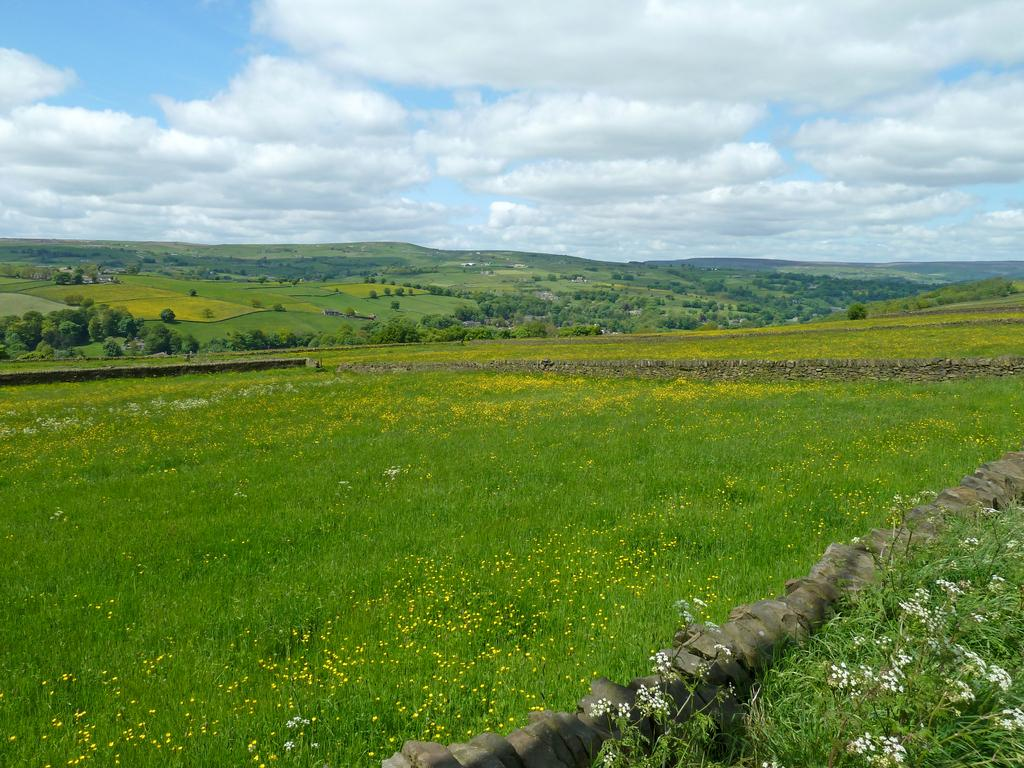What type of vegetation can be seen in the image? There is grass in the image, as well as plants and flowers at the bottom. What is visible in the background of the image? There are trees in the background of the image. What can be seen in the sky in the image? The sky is visible in the image, and clouds are present. What type of art is displayed on the grass in the image? There is no art displayed on the grass in the image; it only shows vegetation and trees. What type of food can be seen in the image? There is no food present in the image; it only shows vegetation, trees, and the sky. 